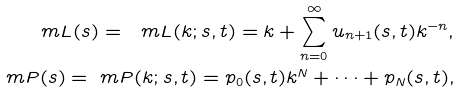<formula> <loc_0><loc_0><loc_500><loc_500>\ m L ( s ) = \ m L ( k ; s , t ) = k + \sum _ { n = 0 } ^ { \infty } u _ { n + 1 } ( s , t ) k ^ { - n } , \\ \ m P ( s ) = \ m P ( k ; s , t ) = p _ { 0 } ( s , t ) k ^ { N } + \cdots + p _ { N } ( s , t ) ,</formula> 